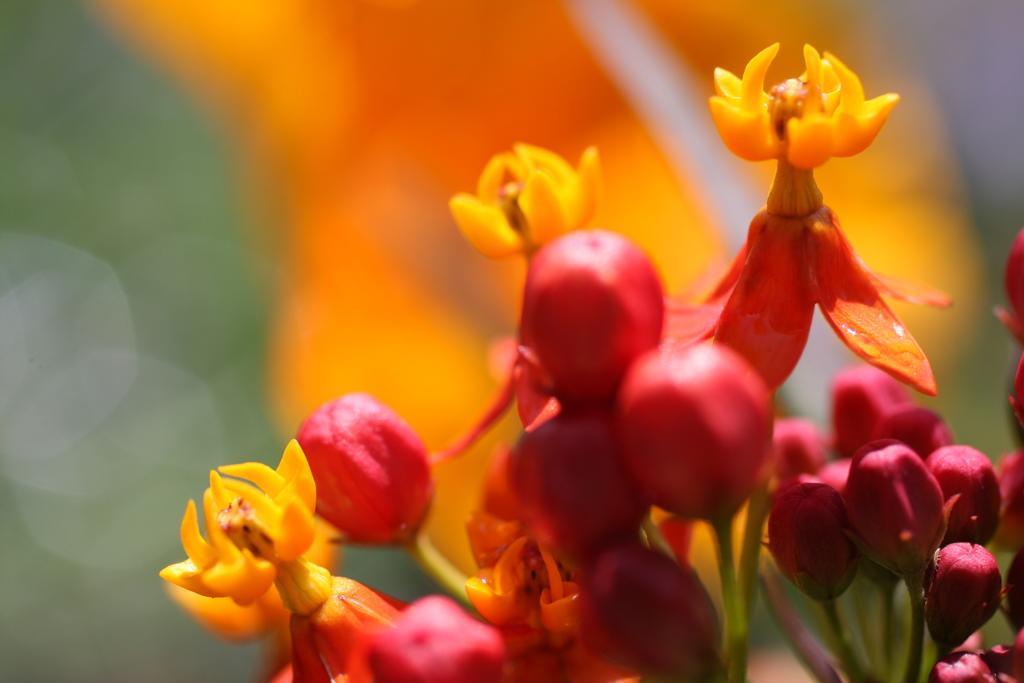Describe this image in one or two sentences. To the right side of the foreground there are flowers and buds of a plant. In the background there is green and orange colored blur image. 